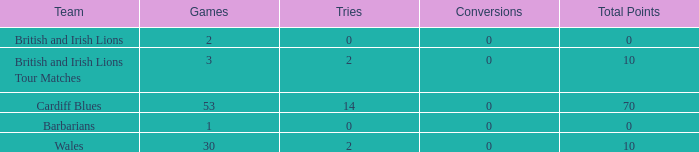What is the smallest number of tries with conversions more than 0? None. 